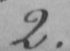Transcribe the text shown in this historical manuscript line. 2 . 